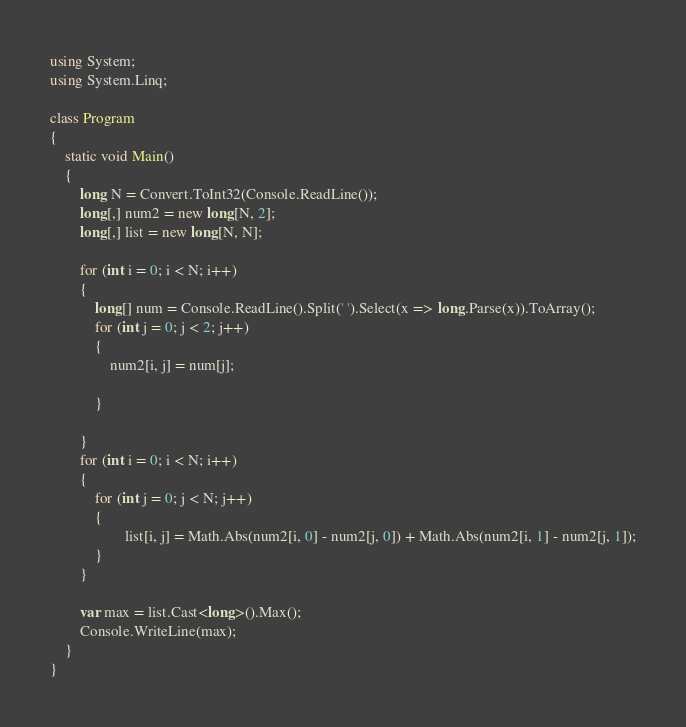Convert code to text. <code><loc_0><loc_0><loc_500><loc_500><_C#_>using System;
using System.Linq;

class Program
{
    static void Main()
    {
        long N = Convert.ToInt32(Console.ReadLine());
        long[,] num2 = new long[N, 2];
        long[,] list = new long[N, N];

        for (int i = 0; i < N; i++)
        {
            long[] num = Console.ReadLine().Split(' ').Select(x => long.Parse(x)).ToArray();
            for (int j = 0; j < 2; j++)
            {
                num2[i, j] = num[j];

            }
            
        }
        for (int i = 0; i < N; i++)
        {
            for (int j = 0; j < N; j++)
            {
                    list[i, j] = Math.Abs(num2[i, 0] - num2[j, 0]) + Math.Abs(num2[i, 1] - num2[j, 1]);
            }
        }

        var max = list.Cast<long>().Max();
        Console.WriteLine(max);
    }
}</code> 